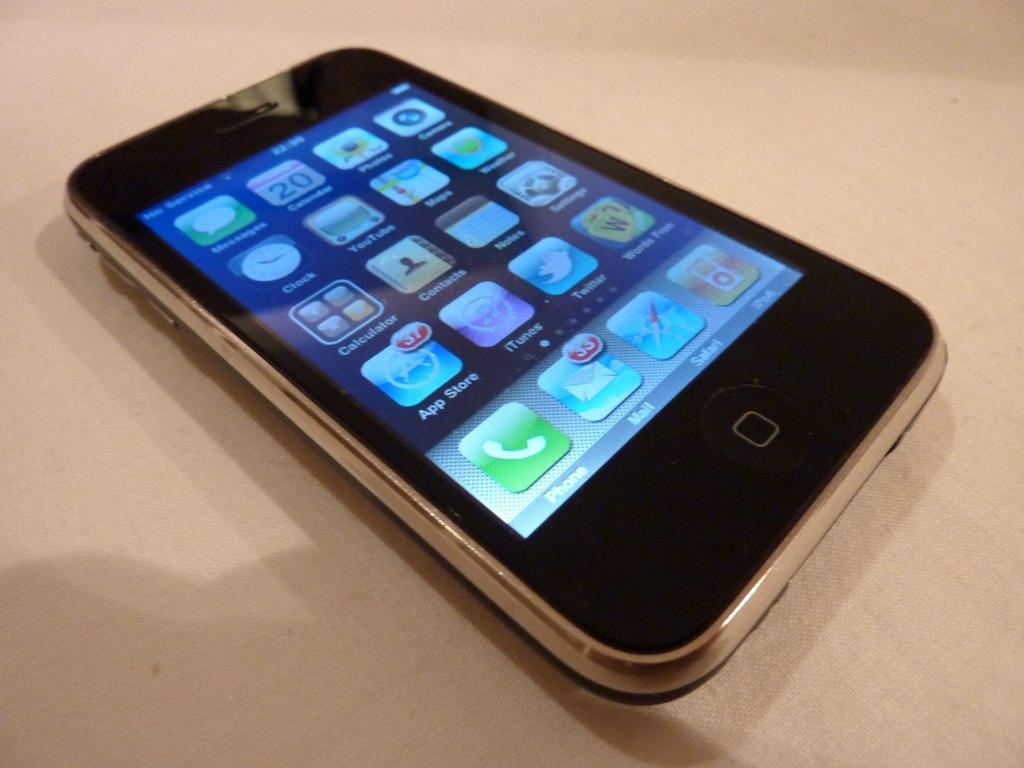What is one of the apps featured on the phone screen?
Offer a very short reply. App store. How many email does this person have?
Ensure brevity in your answer.  33. 